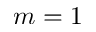<formula> <loc_0><loc_0><loc_500><loc_500>m = 1</formula> 